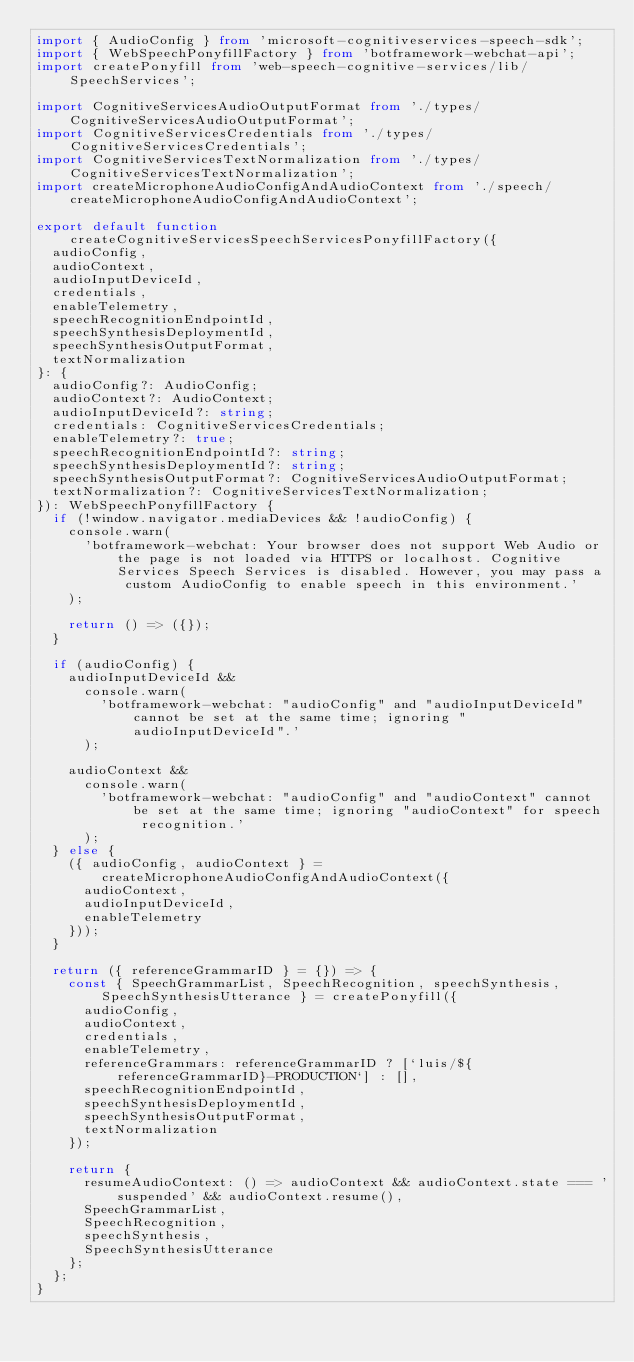Convert code to text. <code><loc_0><loc_0><loc_500><loc_500><_TypeScript_>import { AudioConfig } from 'microsoft-cognitiveservices-speech-sdk';
import { WebSpeechPonyfillFactory } from 'botframework-webchat-api';
import createPonyfill from 'web-speech-cognitive-services/lib/SpeechServices';

import CognitiveServicesAudioOutputFormat from './types/CognitiveServicesAudioOutputFormat';
import CognitiveServicesCredentials from './types/CognitiveServicesCredentials';
import CognitiveServicesTextNormalization from './types/CognitiveServicesTextNormalization';
import createMicrophoneAudioConfigAndAudioContext from './speech/createMicrophoneAudioConfigAndAudioContext';

export default function createCognitiveServicesSpeechServicesPonyfillFactory({
  audioConfig,
  audioContext,
  audioInputDeviceId,
  credentials,
  enableTelemetry,
  speechRecognitionEndpointId,
  speechSynthesisDeploymentId,
  speechSynthesisOutputFormat,
  textNormalization
}: {
  audioConfig?: AudioConfig;
  audioContext?: AudioContext;
  audioInputDeviceId?: string;
  credentials: CognitiveServicesCredentials;
  enableTelemetry?: true;
  speechRecognitionEndpointId?: string;
  speechSynthesisDeploymentId?: string;
  speechSynthesisOutputFormat?: CognitiveServicesAudioOutputFormat;
  textNormalization?: CognitiveServicesTextNormalization;
}): WebSpeechPonyfillFactory {
  if (!window.navigator.mediaDevices && !audioConfig) {
    console.warn(
      'botframework-webchat: Your browser does not support Web Audio or the page is not loaded via HTTPS or localhost. Cognitive Services Speech Services is disabled. However, you may pass a custom AudioConfig to enable speech in this environment.'
    );

    return () => ({});
  }

  if (audioConfig) {
    audioInputDeviceId &&
      console.warn(
        'botframework-webchat: "audioConfig" and "audioInputDeviceId" cannot be set at the same time; ignoring "audioInputDeviceId".'
      );

    audioContext &&
      console.warn(
        'botframework-webchat: "audioConfig" and "audioContext" cannot be set at the same time; ignoring "audioContext" for speech recognition.'
      );
  } else {
    ({ audioConfig, audioContext } = createMicrophoneAudioConfigAndAudioContext({
      audioContext,
      audioInputDeviceId,
      enableTelemetry
    }));
  }

  return ({ referenceGrammarID } = {}) => {
    const { SpeechGrammarList, SpeechRecognition, speechSynthesis, SpeechSynthesisUtterance } = createPonyfill({
      audioConfig,
      audioContext,
      credentials,
      enableTelemetry,
      referenceGrammars: referenceGrammarID ? [`luis/${referenceGrammarID}-PRODUCTION`] : [],
      speechRecognitionEndpointId,
      speechSynthesisDeploymentId,
      speechSynthesisOutputFormat,
      textNormalization
    });

    return {
      resumeAudioContext: () => audioContext && audioContext.state === 'suspended' && audioContext.resume(),
      SpeechGrammarList,
      SpeechRecognition,
      speechSynthesis,
      SpeechSynthesisUtterance
    };
  };
}
</code> 